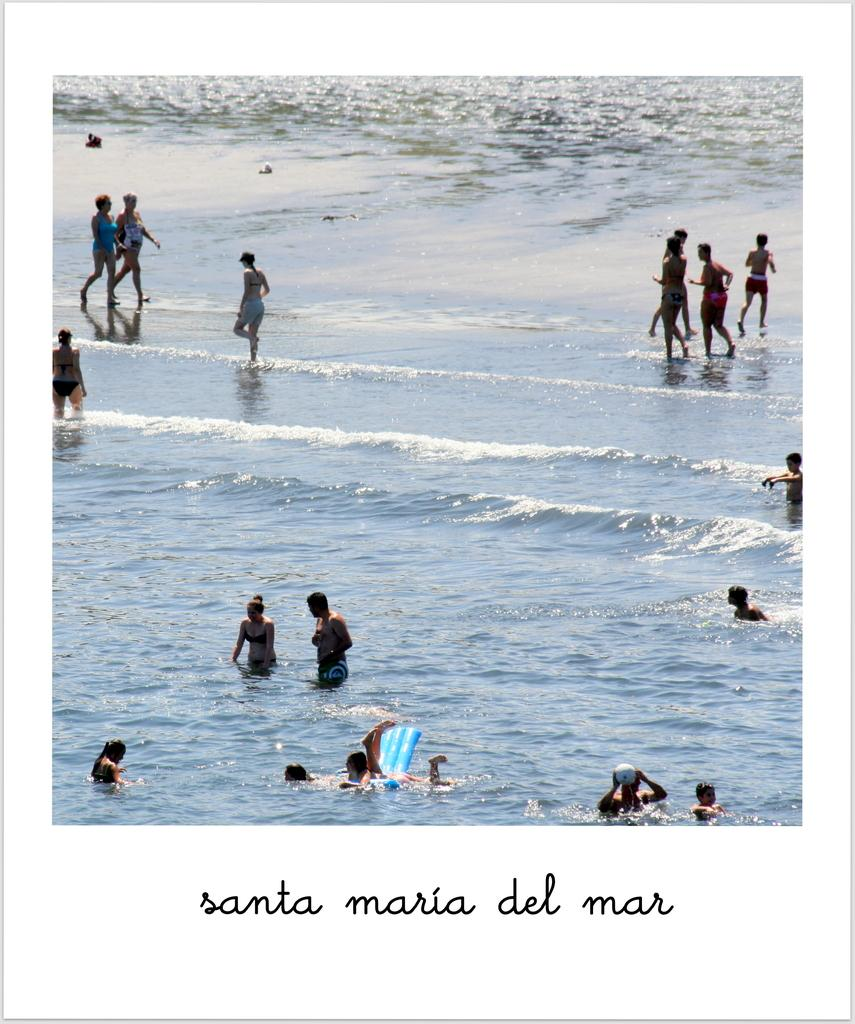What is happening in the image? There is a group of people in the image, and they are walking on the beach. Are there any other activities taking place in the image? Yes, there are persons swimming in the beach. What type of butter can be seen on the plane in the image? There is no plane or butter present in the image; it features a group of people walking on the beach and swimming. 